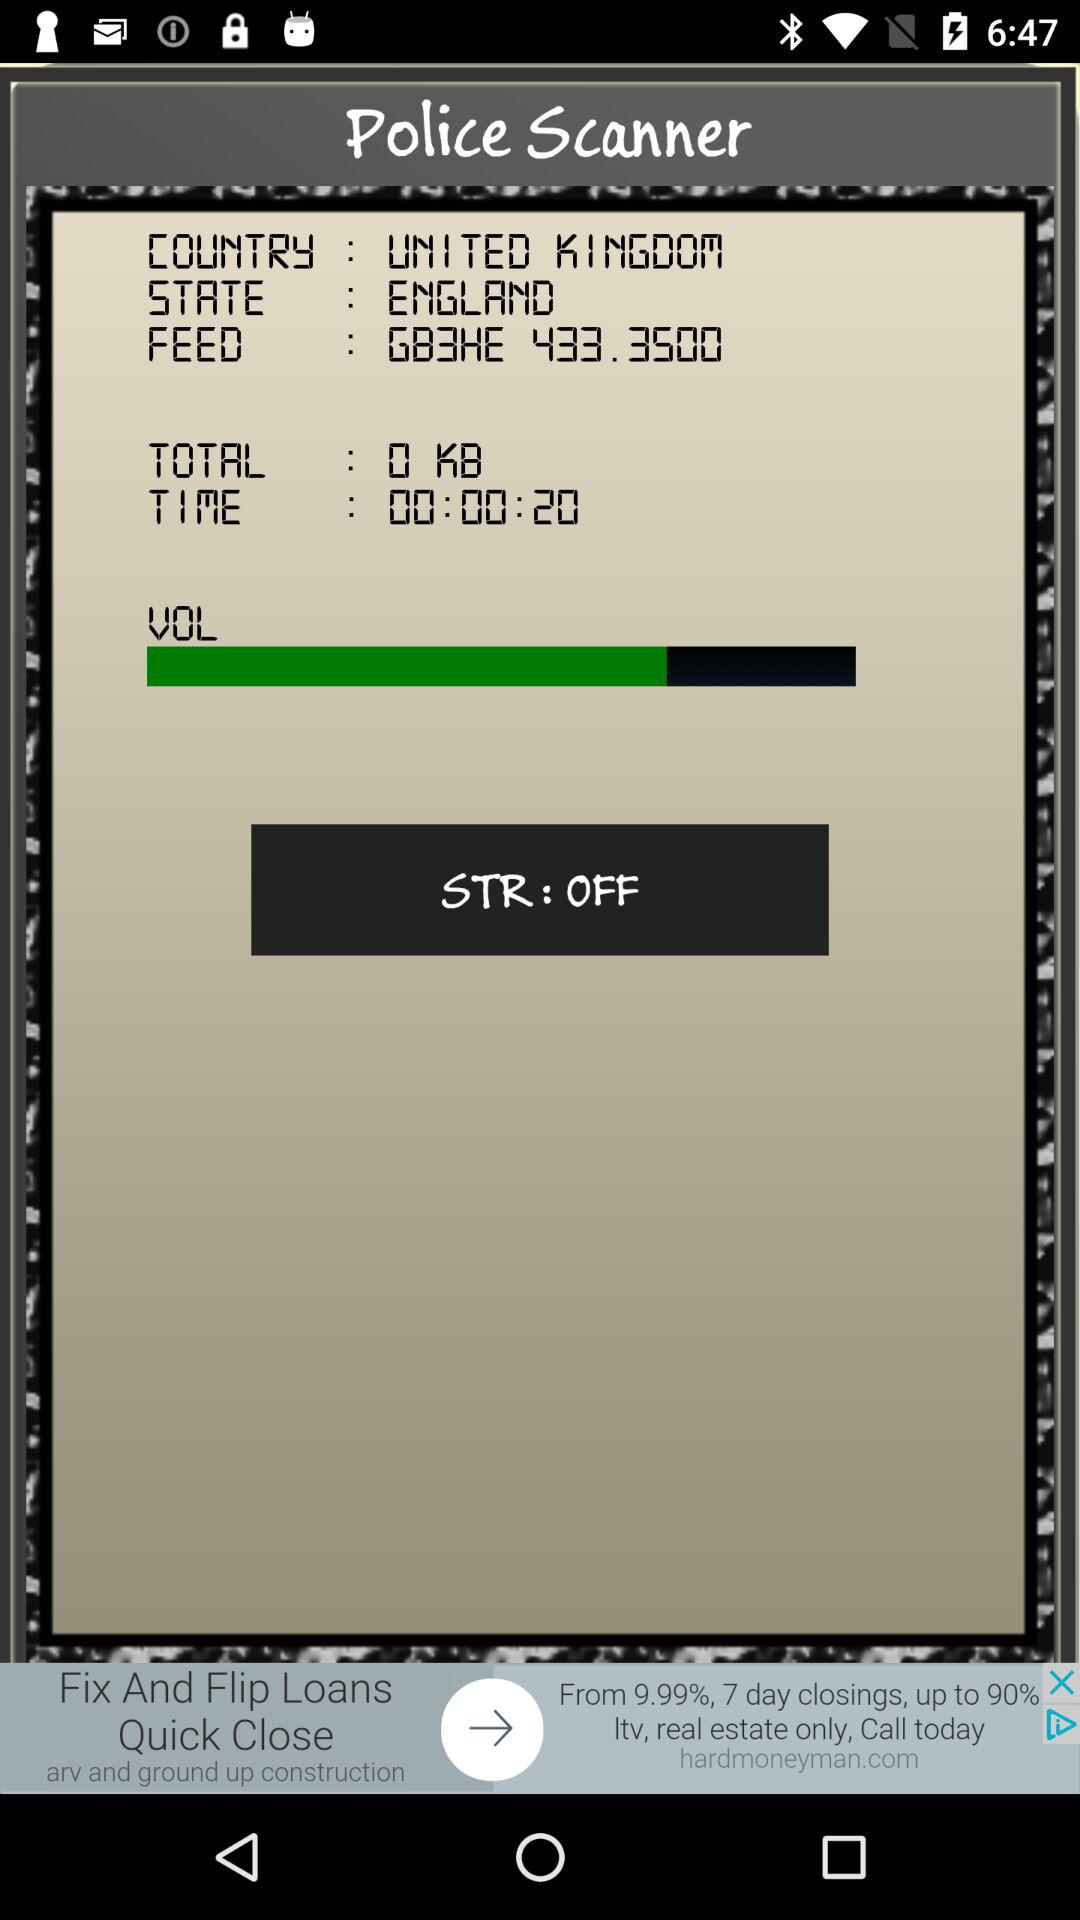Is "STR" on or off? The "STR" is off. 